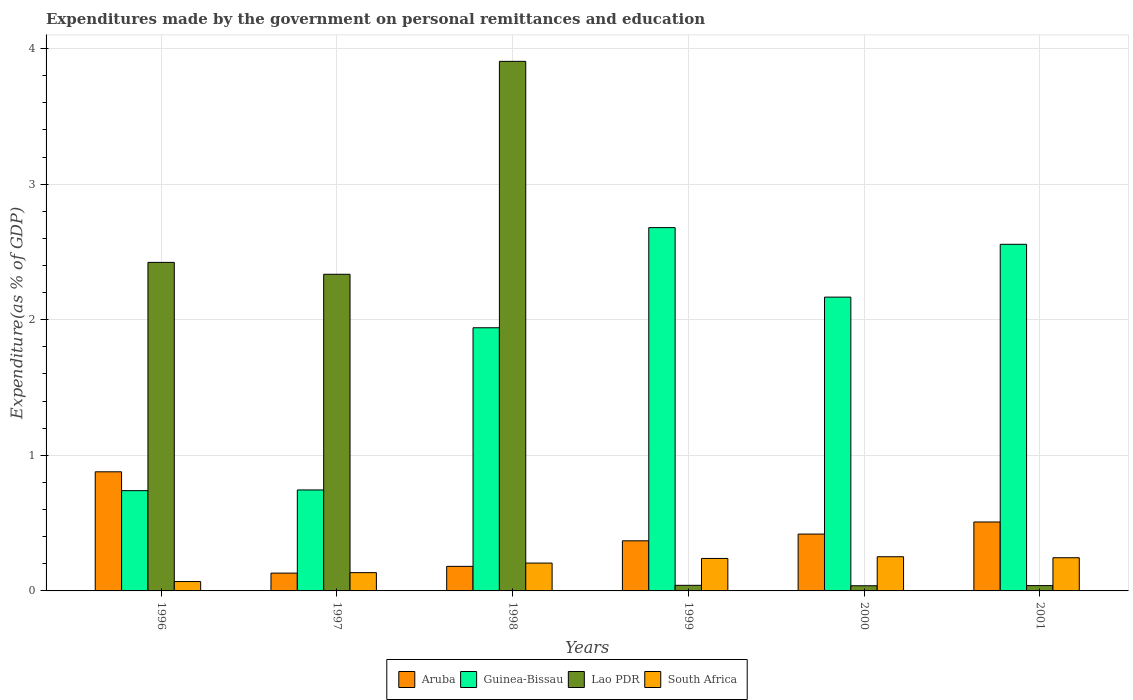Are the number of bars per tick equal to the number of legend labels?
Your answer should be very brief. Yes. Are the number of bars on each tick of the X-axis equal?
Offer a very short reply. Yes. What is the label of the 3rd group of bars from the left?
Ensure brevity in your answer.  1998. What is the expenditures made by the government on personal remittances and education in Guinea-Bissau in 1997?
Keep it short and to the point. 0.74. Across all years, what is the maximum expenditures made by the government on personal remittances and education in Guinea-Bissau?
Give a very brief answer. 2.68. Across all years, what is the minimum expenditures made by the government on personal remittances and education in Aruba?
Your answer should be very brief. 0.13. In which year was the expenditures made by the government on personal remittances and education in Aruba maximum?
Ensure brevity in your answer.  1996. In which year was the expenditures made by the government on personal remittances and education in South Africa minimum?
Keep it short and to the point. 1996. What is the total expenditures made by the government on personal remittances and education in Lao PDR in the graph?
Your answer should be very brief. 8.78. What is the difference between the expenditures made by the government on personal remittances and education in Aruba in 1996 and that in 1997?
Your answer should be compact. 0.75. What is the difference between the expenditures made by the government on personal remittances and education in Lao PDR in 2001 and the expenditures made by the government on personal remittances and education in Aruba in 1999?
Offer a terse response. -0.33. What is the average expenditures made by the government on personal remittances and education in Aruba per year?
Offer a terse response. 0.41. In the year 1998, what is the difference between the expenditures made by the government on personal remittances and education in Lao PDR and expenditures made by the government on personal remittances and education in Aruba?
Provide a succinct answer. 3.72. In how many years, is the expenditures made by the government on personal remittances and education in Aruba greater than 2 %?
Give a very brief answer. 0. What is the ratio of the expenditures made by the government on personal remittances and education in South Africa in 1996 to that in 2000?
Provide a short and direct response. 0.27. Is the difference between the expenditures made by the government on personal remittances and education in Lao PDR in 2000 and 2001 greater than the difference between the expenditures made by the government on personal remittances and education in Aruba in 2000 and 2001?
Keep it short and to the point. Yes. What is the difference between the highest and the second highest expenditures made by the government on personal remittances and education in Lao PDR?
Your answer should be very brief. 1.48. What is the difference between the highest and the lowest expenditures made by the government on personal remittances and education in Aruba?
Offer a terse response. 0.75. In how many years, is the expenditures made by the government on personal remittances and education in South Africa greater than the average expenditures made by the government on personal remittances and education in South Africa taken over all years?
Ensure brevity in your answer.  4. Is the sum of the expenditures made by the government on personal remittances and education in Lao PDR in 1999 and 2000 greater than the maximum expenditures made by the government on personal remittances and education in Guinea-Bissau across all years?
Make the answer very short. No. What does the 4th bar from the left in 1997 represents?
Your answer should be very brief. South Africa. What does the 2nd bar from the right in 1997 represents?
Your response must be concise. Lao PDR. Is it the case that in every year, the sum of the expenditures made by the government on personal remittances and education in Guinea-Bissau and expenditures made by the government on personal remittances and education in Lao PDR is greater than the expenditures made by the government on personal remittances and education in South Africa?
Ensure brevity in your answer.  Yes. How many bars are there?
Your answer should be very brief. 24. Are all the bars in the graph horizontal?
Make the answer very short. No. How many years are there in the graph?
Offer a very short reply. 6. What is the difference between two consecutive major ticks on the Y-axis?
Your response must be concise. 1. Are the values on the major ticks of Y-axis written in scientific E-notation?
Your answer should be compact. No. Does the graph contain any zero values?
Provide a succinct answer. No. How many legend labels are there?
Provide a succinct answer. 4. What is the title of the graph?
Give a very brief answer. Expenditures made by the government on personal remittances and education. What is the label or title of the Y-axis?
Your answer should be compact. Expenditure(as % of GDP). What is the Expenditure(as % of GDP) in Aruba in 1996?
Your response must be concise. 0.88. What is the Expenditure(as % of GDP) in Guinea-Bissau in 1996?
Offer a very short reply. 0.74. What is the Expenditure(as % of GDP) in Lao PDR in 1996?
Give a very brief answer. 2.42. What is the Expenditure(as % of GDP) in South Africa in 1996?
Provide a succinct answer. 0.07. What is the Expenditure(as % of GDP) in Aruba in 1997?
Ensure brevity in your answer.  0.13. What is the Expenditure(as % of GDP) in Guinea-Bissau in 1997?
Keep it short and to the point. 0.74. What is the Expenditure(as % of GDP) of Lao PDR in 1997?
Provide a succinct answer. 2.34. What is the Expenditure(as % of GDP) of South Africa in 1997?
Make the answer very short. 0.13. What is the Expenditure(as % of GDP) in Aruba in 1998?
Keep it short and to the point. 0.18. What is the Expenditure(as % of GDP) of Guinea-Bissau in 1998?
Make the answer very short. 1.94. What is the Expenditure(as % of GDP) of Lao PDR in 1998?
Offer a very short reply. 3.91. What is the Expenditure(as % of GDP) in South Africa in 1998?
Your response must be concise. 0.21. What is the Expenditure(as % of GDP) in Aruba in 1999?
Make the answer very short. 0.37. What is the Expenditure(as % of GDP) in Guinea-Bissau in 1999?
Your answer should be very brief. 2.68. What is the Expenditure(as % of GDP) of Lao PDR in 1999?
Offer a terse response. 0.04. What is the Expenditure(as % of GDP) of South Africa in 1999?
Keep it short and to the point. 0.24. What is the Expenditure(as % of GDP) of Aruba in 2000?
Your answer should be very brief. 0.42. What is the Expenditure(as % of GDP) of Guinea-Bissau in 2000?
Provide a short and direct response. 2.17. What is the Expenditure(as % of GDP) in Lao PDR in 2000?
Your response must be concise. 0.04. What is the Expenditure(as % of GDP) of South Africa in 2000?
Give a very brief answer. 0.25. What is the Expenditure(as % of GDP) in Aruba in 2001?
Ensure brevity in your answer.  0.51. What is the Expenditure(as % of GDP) in Guinea-Bissau in 2001?
Ensure brevity in your answer.  2.56. What is the Expenditure(as % of GDP) of Lao PDR in 2001?
Provide a short and direct response. 0.04. What is the Expenditure(as % of GDP) of South Africa in 2001?
Your answer should be compact. 0.24. Across all years, what is the maximum Expenditure(as % of GDP) in Aruba?
Provide a succinct answer. 0.88. Across all years, what is the maximum Expenditure(as % of GDP) in Guinea-Bissau?
Give a very brief answer. 2.68. Across all years, what is the maximum Expenditure(as % of GDP) of Lao PDR?
Keep it short and to the point. 3.91. Across all years, what is the maximum Expenditure(as % of GDP) in South Africa?
Keep it short and to the point. 0.25. Across all years, what is the minimum Expenditure(as % of GDP) of Aruba?
Make the answer very short. 0.13. Across all years, what is the minimum Expenditure(as % of GDP) of Guinea-Bissau?
Ensure brevity in your answer.  0.74. Across all years, what is the minimum Expenditure(as % of GDP) in Lao PDR?
Provide a succinct answer. 0.04. Across all years, what is the minimum Expenditure(as % of GDP) of South Africa?
Make the answer very short. 0.07. What is the total Expenditure(as % of GDP) of Aruba in the graph?
Make the answer very short. 2.49. What is the total Expenditure(as % of GDP) in Guinea-Bissau in the graph?
Keep it short and to the point. 10.83. What is the total Expenditure(as % of GDP) in Lao PDR in the graph?
Your answer should be compact. 8.78. What is the total Expenditure(as % of GDP) of South Africa in the graph?
Offer a very short reply. 1.15. What is the difference between the Expenditure(as % of GDP) of Aruba in 1996 and that in 1997?
Make the answer very short. 0.75. What is the difference between the Expenditure(as % of GDP) of Guinea-Bissau in 1996 and that in 1997?
Make the answer very short. -0.01. What is the difference between the Expenditure(as % of GDP) of Lao PDR in 1996 and that in 1997?
Provide a short and direct response. 0.09. What is the difference between the Expenditure(as % of GDP) of South Africa in 1996 and that in 1997?
Give a very brief answer. -0.07. What is the difference between the Expenditure(as % of GDP) of Aruba in 1996 and that in 1998?
Give a very brief answer. 0.7. What is the difference between the Expenditure(as % of GDP) in Guinea-Bissau in 1996 and that in 1998?
Your answer should be very brief. -1.2. What is the difference between the Expenditure(as % of GDP) in Lao PDR in 1996 and that in 1998?
Provide a succinct answer. -1.48. What is the difference between the Expenditure(as % of GDP) in South Africa in 1996 and that in 1998?
Give a very brief answer. -0.14. What is the difference between the Expenditure(as % of GDP) in Aruba in 1996 and that in 1999?
Make the answer very short. 0.51. What is the difference between the Expenditure(as % of GDP) of Guinea-Bissau in 1996 and that in 1999?
Keep it short and to the point. -1.94. What is the difference between the Expenditure(as % of GDP) in Lao PDR in 1996 and that in 1999?
Provide a short and direct response. 2.38. What is the difference between the Expenditure(as % of GDP) of South Africa in 1996 and that in 1999?
Keep it short and to the point. -0.17. What is the difference between the Expenditure(as % of GDP) of Aruba in 1996 and that in 2000?
Give a very brief answer. 0.46. What is the difference between the Expenditure(as % of GDP) in Guinea-Bissau in 1996 and that in 2000?
Keep it short and to the point. -1.43. What is the difference between the Expenditure(as % of GDP) in Lao PDR in 1996 and that in 2000?
Your answer should be compact. 2.38. What is the difference between the Expenditure(as % of GDP) of South Africa in 1996 and that in 2000?
Provide a succinct answer. -0.18. What is the difference between the Expenditure(as % of GDP) of Aruba in 1996 and that in 2001?
Offer a very short reply. 0.37. What is the difference between the Expenditure(as % of GDP) of Guinea-Bissau in 1996 and that in 2001?
Your response must be concise. -1.82. What is the difference between the Expenditure(as % of GDP) in Lao PDR in 1996 and that in 2001?
Ensure brevity in your answer.  2.38. What is the difference between the Expenditure(as % of GDP) of South Africa in 1996 and that in 2001?
Provide a succinct answer. -0.18. What is the difference between the Expenditure(as % of GDP) of Aruba in 1997 and that in 1998?
Provide a succinct answer. -0.05. What is the difference between the Expenditure(as % of GDP) of Guinea-Bissau in 1997 and that in 1998?
Offer a terse response. -1.2. What is the difference between the Expenditure(as % of GDP) in Lao PDR in 1997 and that in 1998?
Ensure brevity in your answer.  -1.57. What is the difference between the Expenditure(as % of GDP) in South Africa in 1997 and that in 1998?
Your answer should be compact. -0.07. What is the difference between the Expenditure(as % of GDP) of Aruba in 1997 and that in 1999?
Make the answer very short. -0.24. What is the difference between the Expenditure(as % of GDP) of Guinea-Bissau in 1997 and that in 1999?
Keep it short and to the point. -1.93. What is the difference between the Expenditure(as % of GDP) of Lao PDR in 1997 and that in 1999?
Ensure brevity in your answer.  2.29. What is the difference between the Expenditure(as % of GDP) in South Africa in 1997 and that in 1999?
Give a very brief answer. -0.1. What is the difference between the Expenditure(as % of GDP) in Aruba in 1997 and that in 2000?
Provide a succinct answer. -0.29. What is the difference between the Expenditure(as % of GDP) in Guinea-Bissau in 1997 and that in 2000?
Provide a succinct answer. -1.42. What is the difference between the Expenditure(as % of GDP) in Lao PDR in 1997 and that in 2000?
Ensure brevity in your answer.  2.3. What is the difference between the Expenditure(as % of GDP) of South Africa in 1997 and that in 2000?
Make the answer very short. -0.12. What is the difference between the Expenditure(as % of GDP) of Aruba in 1997 and that in 2001?
Offer a very short reply. -0.38. What is the difference between the Expenditure(as % of GDP) in Guinea-Bissau in 1997 and that in 2001?
Offer a very short reply. -1.81. What is the difference between the Expenditure(as % of GDP) in Lao PDR in 1997 and that in 2001?
Your answer should be compact. 2.3. What is the difference between the Expenditure(as % of GDP) of South Africa in 1997 and that in 2001?
Your answer should be compact. -0.11. What is the difference between the Expenditure(as % of GDP) of Aruba in 1998 and that in 1999?
Provide a short and direct response. -0.19. What is the difference between the Expenditure(as % of GDP) in Guinea-Bissau in 1998 and that in 1999?
Give a very brief answer. -0.74. What is the difference between the Expenditure(as % of GDP) of Lao PDR in 1998 and that in 1999?
Ensure brevity in your answer.  3.86. What is the difference between the Expenditure(as % of GDP) in South Africa in 1998 and that in 1999?
Ensure brevity in your answer.  -0.03. What is the difference between the Expenditure(as % of GDP) in Aruba in 1998 and that in 2000?
Give a very brief answer. -0.24. What is the difference between the Expenditure(as % of GDP) in Guinea-Bissau in 1998 and that in 2000?
Offer a terse response. -0.23. What is the difference between the Expenditure(as % of GDP) in Lao PDR in 1998 and that in 2000?
Provide a short and direct response. 3.87. What is the difference between the Expenditure(as % of GDP) in South Africa in 1998 and that in 2000?
Give a very brief answer. -0.05. What is the difference between the Expenditure(as % of GDP) of Aruba in 1998 and that in 2001?
Ensure brevity in your answer.  -0.33. What is the difference between the Expenditure(as % of GDP) of Guinea-Bissau in 1998 and that in 2001?
Your answer should be compact. -0.62. What is the difference between the Expenditure(as % of GDP) in Lao PDR in 1998 and that in 2001?
Provide a succinct answer. 3.87. What is the difference between the Expenditure(as % of GDP) in South Africa in 1998 and that in 2001?
Make the answer very short. -0.04. What is the difference between the Expenditure(as % of GDP) in Aruba in 1999 and that in 2000?
Offer a terse response. -0.05. What is the difference between the Expenditure(as % of GDP) in Guinea-Bissau in 1999 and that in 2000?
Provide a short and direct response. 0.51. What is the difference between the Expenditure(as % of GDP) of Lao PDR in 1999 and that in 2000?
Offer a very short reply. 0. What is the difference between the Expenditure(as % of GDP) in South Africa in 1999 and that in 2000?
Make the answer very short. -0.01. What is the difference between the Expenditure(as % of GDP) in Aruba in 1999 and that in 2001?
Offer a terse response. -0.14. What is the difference between the Expenditure(as % of GDP) of Guinea-Bissau in 1999 and that in 2001?
Your answer should be very brief. 0.12. What is the difference between the Expenditure(as % of GDP) in Lao PDR in 1999 and that in 2001?
Ensure brevity in your answer.  0. What is the difference between the Expenditure(as % of GDP) in South Africa in 1999 and that in 2001?
Make the answer very short. -0.01. What is the difference between the Expenditure(as % of GDP) in Aruba in 2000 and that in 2001?
Offer a very short reply. -0.09. What is the difference between the Expenditure(as % of GDP) of Guinea-Bissau in 2000 and that in 2001?
Your response must be concise. -0.39. What is the difference between the Expenditure(as % of GDP) in Lao PDR in 2000 and that in 2001?
Ensure brevity in your answer.  -0. What is the difference between the Expenditure(as % of GDP) in South Africa in 2000 and that in 2001?
Provide a short and direct response. 0.01. What is the difference between the Expenditure(as % of GDP) of Aruba in 1996 and the Expenditure(as % of GDP) of Guinea-Bissau in 1997?
Provide a short and direct response. 0.13. What is the difference between the Expenditure(as % of GDP) of Aruba in 1996 and the Expenditure(as % of GDP) of Lao PDR in 1997?
Keep it short and to the point. -1.46. What is the difference between the Expenditure(as % of GDP) in Aruba in 1996 and the Expenditure(as % of GDP) in South Africa in 1997?
Offer a very short reply. 0.74. What is the difference between the Expenditure(as % of GDP) in Guinea-Bissau in 1996 and the Expenditure(as % of GDP) in Lao PDR in 1997?
Offer a very short reply. -1.6. What is the difference between the Expenditure(as % of GDP) of Guinea-Bissau in 1996 and the Expenditure(as % of GDP) of South Africa in 1997?
Your response must be concise. 0.6. What is the difference between the Expenditure(as % of GDP) of Lao PDR in 1996 and the Expenditure(as % of GDP) of South Africa in 1997?
Ensure brevity in your answer.  2.29. What is the difference between the Expenditure(as % of GDP) in Aruba in 1996 and the Expenditure(as % of GDP) in Guinea-Bissau in 1998?
Provide a short and direct response. -1.06. What is the difference between the Expenditure(as % of GDP) in Aruba in 1996 and the Expenditure(as % of GDP) in Lao PDR in 1998?
Provide a short and direct response. -3.03. What is the difference between the Expenditure(as % of GDP) of Aruba in 1996 and the Expenditure(as % of GDP) of South Africa in 1998?
Offer a very short reply. 0.67. What is the difference between the Expenditure(as % of GDP) in Guinea-Bissau in 1996 and the Expenditure(as % of GDP) in Lao PDR in 1998?
Ensure brevity in your answer.  -3.17. What is the difference between the Expenditure(as % of GDP) of Guinea-Bissau in 1996 and the Expenditure(as % of GDP) of South Africa in 1998?
Give a very brief answer. 0.53. What is the difference between the Expenditure(as % of GDP) of Lao PDR in 1996 and the Expenditure(as % of GDP) of South Africa in 1998?
Give a very brief answer. 2.22. What is the difference between the Expenditure(as % of GDP) in Aruba in 1996 and the Expenditure(as % of GDP) in Guinea-Bissau in 1999?
Your answer should be compact. -1.8. What is the difference between the Expenditure(as % of GDP) of Aruba in 1996 and the Expenditure(as % of GDP) of Lao PDR in 1999?
Give a very brief answer. 0.84. What is the difference between the Expenditure(as % of GDP) of Aruba in 1996 and the Expenditure(as % of GDP) of South Africa in 1999?
Ensure brevity in your answer.  0.64. What is the difference between the Expenditure(as % of GDP) in Guinea-Bissau in 1996 and the Expenditure(as % of GDP) in Lao PDR in 1999?
Ensure brevity in your answer.  0.7. What is the difference between the Expenditure(as % of GDP) in Guinea-Bissau in 1996 and the Expenditure(as % of GDP) in South Africa in 1999?
Give a very brief answer. 0.5. What is the difference between the Expenditure(as % of GDP) of Lao PDR in 1996 and the Expenditure(as % of GDP) of South Africa in 1999?
Make the answer very short. 2.18. What is the difference between the Expenditure(as % of GDP) in Aruba in 1996 and the Expenditure(as % of GDP) in Guinea-Bissau in 2000?
Give a very brief answer. -1.29. What is the difference between the Expenditure(as % of GDP) of Aruba in 1996 and the Expenditure(as % of GDP) of Lao PDR in 2000?
Your answer should be very brief. 0.84. What is the difference between the Expenditure(as % of GDP) in Aruba in 1996 and the Expenditure(as % of GDP) in South Africa in 2000?
Your answer should be compact. 0.63. What is the difference between the Expenditure(as % of GDP) in Guinea-Bissau in 1996 and the Expenditure(as % of GDP) in Lao PDR in 2000?
Offer a terse response. 0.7. What is the difference between the Expenditure(as % of GDP) in Guinea-Bissau in 1996 and the Expenditure(as % of GDP) in South Africa in 2000?
Keep it short and to the point. 0.49. What is the difference between the Expenditure(as % of GDP) of Lao PDR in 1996 and the Expenditure(as % of GDP) of South Africa in 2000?
Your answer should be compact. 2.17. What is the difference between the Expenditure(as % of GDP) of Aruba in 1996 and the Expenditure(as % of GDP) of Guinea-Bissau in 2001?
Offer a terse response. -1.68. What is the difference between the Expenditure(as % of GDP) in Aruba in 1996 and the Expenditure(as % of GDP) in Lao PDR in 2001?
Offer a very short reply. 0.84. What is the difference between the Expenditure(as % of GDP) of Aruba in 1996 and the Expenditure(as % of GDP) of South Africa in 2001?
Give a very brief answer. 0.63. What is the difference between the Expenditure(as % of GDP) of Guinea-Bissau in 1996 and the Expenditure(as % of GDP) of Lao PDR in 2001?
Your response must be concise. 0.7. What is the difference between the Expenditure(as % of GDP) of Guinea-Bissau in 1996 and the Expenditure(as % of GDP) of South Africa in 2001?
Offer a very short reply. 0.49. What is the difference between the Expenditure(as % of GDP) in Lao PDR in 1996 and the Expenditure(as % of GDP) in South Africa in 2001?
Offer a terse response. 2.18. What is the difference between the Expenditure(as % of GDP) of Aruba in 1997 and the Expenditure(as % of GDP) of Guinea-Bissau in 1998?
Provide a short and direct response. -1.81. What is the difference between the Expenditure(as % of GDP) in Aruba in 1997 and the Expenditure(as % of GDP) in Lao PDR in 1998?
Provide a succinct answer. -3.77. What is the difference between the Expenditure(as % of GDP) of Aruba in 1997 and the Expenditure(as % of GDP) of South Africa in 1998?
Offer a terse response. -0.07. What is the difference between the Expenditure(as % of GDP) of Guinea-Bissau in 1997 and the Expenditure(as % of GDP) of Lao PDR in 1998?
Make the answer very short. -3.16. What is the difference between the Expenditure(as % of GDP) of Guinea-Bissau in 1997 and the Expenditure(as % of GDP) of South Africa in 1998?
Make the answer very short. 0.54. What is the difference between the Expenditure(as % of GDP) in Lao PDR in 1997 and the Expenditure(as % of GDP) in South Africa in 1998?
Offer a terse response. 2.13. What is the difference between the Expenditure(as % of GDP) of Aruba in 1997 and the Expenditure(as % of GDP) of Guinea-Bissau in 1999?
Offer a very short reply. -2.55. What is the difference between the Expenditure(as % of GDP) in Aruba in 1997 and the Expenditure(as % of GDP) in Lao PDR in 1999?
Ensure brevity in your answer.  0.09. What is the difference between the Expenditure(as % of GDP) in Aruba in 1997 and the Expenditure(as % of GDP) in South Africa in 1999?
Offer a terse response. -0.11. What is the difference between the Expenditure(as % of GDP) of Guinea-Bissau in 1997 and the Expenditure(as % of GDP) of Lao PDR in 1999?
Your response must be concise. 0.7. What is the difference between the Expenditure(as % of GDP) of Guinea-Bissau in 1997 and the Expenditure(as % of GDP) of South Africa in 1999?
Your answer should be very brief. 0.51. What is the difference between the Expenditure(as % of GDP) in Lao PDR in 1997 and the Expenditure(as % of GDP) in South Africa in 1999?
Offer a very short reply. 2.1. What is the difference between the Expenditure(as % of GDP) in Aruba in 1997 and the Expenditure(as % of GDP) in Guinea-Bissau in 2000?
Ensure brevity in your answer.  -2.04. What is the difference between the Expenditure(as % of GDP) in Aruba in 1997 and the Expenditure(as % of GDP) in Lao PDR in 2000?
Offer a very short reply. 0.09. What is the difference between the Expenditure(as % of GDP) of Aruba in 1997 and the Expenditure(as % of GDP) of South Africa in 2000?
Your response must be concise. -0.12. What is the difference between the Expenditure(as % of GDP) in Guinea-Bissau in 1997 and the Expenditure(as % of GDP) in Lao PDR in 2000?
Keep it short and to the point. 0.71. What is the difference between the Expenditure(as % of GDP) in Guinea-Bissau in 1997 and the Expenditure(as % of GDP) in South Africa in 2000?
Keep it short and to the point. 0.49. What is the difference between the Expenditure(as % of GDP) of Lao PDR in 1997 and the Expenditure(as % of GDP) of South Africa in 2000?
Provide a succinct answer. 2.08. What is the difference between the Expenditure(as % of GDP) of Aruba in 1997 and the Expenditure(as % of GDP) of Guinea-Bissau in 2001?
Your response must be concise. -2.43. What is the difference between the Expenditure(as % of GDP) of Aruba in 1997 and the Expenditure(as % of GDP) of Lao PDR in 2001?
Your answer should be very brief. 0.09. What is the difference between the Expenditure(as % of GDP) of Aruba in 1997 and the Expenditure(as % of GDP) of South Africa in 2001?
Provide a short and direct response. -0.11. What is the difference between the Expenditure(as % of GDP) of Guinea-Bissau in 1997 and the Expenditure(as % of GDP) of Lao PDR in 2001?
Provide a short and direct response. 0.71. What is the difference between the Expenditure(as % of GDP) in Guinea-Bissau in 1997 and the Expenditure(as % of GDP) in South Africa in 2001?
Offer a very short reply. 0.5. What is the difference between the Expenditure(as % of GDP) of Lao PDR in 1997 and the Expenditure(as % of GDP) of South Africa in 2001?
Keep it short and to the point. 2.09. What is the difference between the Expenditure(as % of GDP) of Aruba in 1998 and the Expenditure(as % of GDP) of Guinea-Bissau in 1999?
Make the answer very short. -2.5. What is the difference between the Expenditure(as % of GDP) of Aruba in 1998 and the Expenditure(as % of GDP) of Lao PDR in 1999?
Provide a short and direct response. 0.14. What is the difference between the Expenditure(as % of GDP) in Aruba in 1998 and the Expenditure(as % of GDP) in South Africa in 1999?
Make the answer very short. -0.06. What is the difference between the Expenditure(as % of GDP) of Guinea-Bissau in 1998 and the Expenditure(as % of GDP) of Lao PDR in 1999?
Give a very brief answer. 1.9. What is the difference between the Expenditure(as % of GDP) in Guinea-Bissau in 1998 and the Expenditure(as % of GDP) in South Africa in 1999?
Offer a terse response. 1.7. What is the difference between the Expenditure(as % of GDP) of Lao PDR in 1998 and the Expenditure(as % of GDP) of South Africa in 1999?
Give a very brief answer. 3.67. What is the difference between the Expenditure(as % of GDP) of Aruba in 1998 and the Expenditure(as % of GDP) of Guinea-Bissau in 2000?
Ensure brevity in your answer.  -1.99. What is the difference between the Expenditure(as % of GDP) in Aruba in 1998 and the Expenditure(as % of GDP) in Lao PDR in 2000?
Give a very brief answer. 0.14. What is the difference between the Expenditure(as % of GDP) of Aruba in 1998 and the Expenditure(as % of GDP) of South Africa in 2000?
Provide a short and direct response. -0.07. What is the difference between the Expenditure(as % of GDP) of Guinea-Bissau in 1998 and the Expenditure(as % of GDP) of Lao PDR in 2000?
Your answer should be compact. 1.9. What is the difference between the Expenditure(as % of GDP) of Guinea-Bissau in 1998 and the Expenditure(as % of GDP) of South Africa in 2000?
Ensure brevity in your answer.  1.69. What is the difference between the Expenditure(as % of GDP) of Lao PDR in 1998 and the Expenditure(as % of GDP) of South Africa in 2000?
Your answer should be compact. 3.65. What is the difference between the Expenditure(as % of GDP) in Aruba in 1998 and the Expenditure(as % of GDP) in Guinea-Bissau in 2001?
Your answer should be very brief. -2.38. What is the difference between the Expenditure(as % of GDP) in Aruba in 1998 and the Expenditure(as % of GDP) in Lao PDR in 2001?
Provide a succinct answer. 0.14. What is the difference between the Expenditure(as % of GDP) of Aruba in 1998 and the Expenditure(as % of GDP) of South Africa in 2001?
Keep it short and to the point. -0.06. What is the difference between the Expenditure(as % of GDP) in Guinea-Bissau in 1998 and the Expenditure(as % of GDP) in Lao PDR in 2001?
Provide a succinct answer. 1.9. What is the difference between the Expenditure(as % of GDP) in Guinea-Bissau in 1998 and the Expenditure(as % of GDP) in South Africa in 2001?
Keep it short and to the point. 1.7. What is the difference between the Expenditure(as % of GDP) in Lao PDR in 1998 and the Expenditure(as % of GDP) in South Africa in 2001?
Your answer should be very brief. 3.66. What is the difference between the Expenditure(as % of GDP) of Aruba in 1999 and the Expenditure(as % of GDP) of Guinea-Bissau in 2000?
Provide a succinct answer. -1.8. What is the difference between the Expenditure(as % of GDP) of Aruba in 1999 and the Expenditure(as % of GDP) of Lao PDR in 2000?
Ensure brevity in your answer.  0.33. What is the difference between the Expenditure(as % of GDP) of Aruba in 1999 and the Expenditure(as % of GDP) of South Africa in 2000?
Make the answer very short. 0.12. What is the difference between the Expenditure(as % of GDP) of Guinea-Bissau in 1999 and the Expenditure(as % of GDP) of Lao PDR in 2000?
Your answer should be very brief. 2.64. What is the difference between the Expenditure(as % of GDP) in Guinea-Bissau in 1999 and the Expenditure(as % of GDP) in South Africa in 2000?
Keep it short and to the point. 2.43. What is the difference between the Expenditure(as % of GDP) of Lao PDR in 1999 and the Expenditure(as % of GDP) of South Africa in 2000?
Your response must be concise. -0.21. What is the difference between the Expenditure(as % of GDP) in Aruba in 1999 and the Expenditure(as % of GDP) in Guinea-Bissau in 2001?
Provide a short and direct response. -2.19. What is the difference between the Expenditure(as % of GDP) in Aruba in 1999 and the Expenditure(as % of GDP) in Lao PDR in 2001?
Make the answer very short. 0.33. What is the difference between the Expenditure(as % of GDP) in Aruba in 1999 and the Expenditure(as % of GDP) in South Africa in 2001?
Make the answer very short. 0.12. What is the difference between the Expenditure(as % of GDP) in Guinea-Bissau in 1999 and the Expenditure(as % of GDP) in Lao PDR in 2001?
Your answer should be compact. 2.64. What is the difference between the Expenditure(as % of GDP) in Guinea-Bissau in 1999 and the Expenditure(as % of GDP) in South Africa in 2001?
Keep it short and to the point. 2.43. What is the difference between the Expenditure(as % of GDP) in Lao PDR in 1999 and the Expenditure(as % of GDP) in South Africa in 2001?
Make the answer very short. -0.2. What is the difference between the Expenditure(as % of GDP) of Aruba in 2000 and the Expenditure(as % of GDP) of Guinea-Bissau in 2001?
Give a very brief answer. -2.14. What is the difference between the Expenditure(as % of GDP) of Aruba in 2000 and the Expenditure(as % of GDP) of Lao PDR in 2001?
Provide a short and direct response. 0.38. What is the difference between the Expenditure(as % of GDP) in Aruba in 2000 and the Expenditure(as % of GDP) in South Africa in 2001?
Your answer should be very brief. 0.17. What is the difference between the Expenditure(as % of GDP) of Guinea-Bissau in 2000 and the Expenditure(as % of GDP) of Lao PDR in 2001?
Offer a very short reply. 2.13. What is the difference between the Expenditure(as % of GDP) in Guinea-Bissau in 2000 and the Expenditure(as % of GDP) in South Africa in 2001?
Keep it short and to the point. 1.92. What is the difference between the Expenditure(as % of GDP) in Lao PDR in 2000 and the Expenditure(as % of GDP) in South Africa in 2001?
Offer a very short reply. -0.21. What is the average Expenditure(as % of GDP) in Aruba per year?
Offer a terse response. 0.41. What is the average Expenditure(as % of GDP) in Guinea-Bissau per year?
Keep it short and to the point. 1.8. What is the average Expenditure(as % of GDP) of Lao PDR per year?
Provide a short and direct response. 1.46. What is the average Expenditure(as % of GDP) in South Africa per year?
Your answer should be very brief. 0.19. In the year 1996, what is the difference between the Expenditure(as % of GDP) in Aruba and Expenditure(as % of GDP) in Guinea-Bissau?
Give a very brief answer. 0.14. In the year 1996, what is the difference between the Expenditure(as % of GDP) in Aruba and Expenditure(as % of GDP) in Lao PDR?
Offer a terse response. -1.54. In the year 1996, what is the difference between the Expenditure(as % of GDP) in Aruba and Expenditure(as % of GDP) in South Africa?
Make the answer very short. 0.81. In the year 1996, what is the difference between the Expenditure(as % of GDP) in Guinea-Bissau and Expenditure(as % of GDP) in Lao PDR?
Offer a very short reply. -1.68. In the year 1996, what is the difference between the Expenditure(as % of GDP) of Guinea-Bissau and Expenditure(as % of GDP) of South Africa?
Your answer should be compact. 0.67. In the year 1996, what is the difference between the Expenditure(as % of GDP) of Lao PDR and Expenditure(as % of GDP) of South Africa?
Your answer should be very brief. 2.35. In the year 1997, what is the difference between the Expenditure(as % of GDP) in Aruba and Expenditure(as % of GDP) in Guinea-Bissau?
Your answer should be compact. -0.61. In the year 1997, what is the difference between the Expenditure(as % of GDP) of Aruba and Expenditure(as % of GDP) of Lao PDR?
Ensure brevity in your answer.  -2.2. In the year 1997, what is the difference between the Expenditure(as % of GDP) in Aruba and Expenditure(as % of GDP) in South Africa?
Your answer should be compact. -0. In the year 1997, what is the difference between the Expenditure(as % of GDP) of Guinea-Bissau and Expenditure(as % of GDP) of Lao PDR?
Your response must be concise. -1.59. In the year 1997, what is the difference between the Expenditure(as % of GDP) in Guinea-Bissau and Expenditure(as % of GDP) in South Africa?
Offer a terse response. 0.61. In the year 1997, what is the difference between the Expenditure(as % of GDP) of Lao PDR and Expenditure(as % of GDP) of South Africa?
Provide a short and direct response. 2.2. In the year 1998, what is the difference between the Expenditure(as % of GDP) in Aruba and Expenditure(as % of GDP) in Guinea-Bissau?
Offer a very short reply. -1.76. In the year 1998, what is the difference between the Expenditure(as % of GDP) of Aruba and Expenditure(as % of GDP) of Lao PDR?
Provide a short and direct response. -3.72. In the year 1998, what is the difference between the Expenditure(as % of GDP) of Aruba and Expenditure(as % of GDP) of South Africa?
Offer a very short reply. -0.02. In the year 1998, what is the difference between the Expenditure(as % of GDP) of Guinea-Bissau and Expenditure(as % of GDP) of Lao PDR?
Your response must be concise. -1.96. In the year 1998, what is the difference between the Expenditure(as % of GDP) in Guinea-Bissau and Expenditure(as % of GDP) in South Africa?
Your response must be concise. 1.74. In the year 1998, what is the difference between the Expenditure(as % of GDP) in Lao PDR and Expenditure(as % of GDP) in South Africa?
Your answer should be compact. 3.7. In the year 1999, what is the difference between the Expenditure(as % of GDP) of Aruba and Expenditure(as % of GDP) of Guinea-Bissau?
Your response must be concise. -2.31. In the year 1999, what is the difference between the Expenditure(as % of GDP) in Aruba and Expenditure(as % of GDP) in Lao PDR?
Ensure brevity in your answer.  0.33. In the year 1999, what is the difference between the Expenditure(as % of GDP) in Aruba and Expenditure(as % of GDP) in South Africa?
Offer a very short reply. 0.13. In the year 1999, what is the difference between the Expenditure(as % of GDP) in Guinea-Bissau and Expenditure(as % of GDP) in Lao PDR?
Offer a terse response. 2.64. In the year 1999, what is the difference between the Expenditure(as % of GDP) of Guinea-Bissau and Expenditure(as % of GDP) of South Africa?
Keep it short and to the point. 2.44. In the year 1999, what is the difference between the Expenditure(as % of GDP) in Lao PDR and Expenditure(as % of GDP) in South Africa?
Provide a succinct answer. -0.2. In the year 2000, what is the difference between the Expenditure(as % of GDP) in Aruba and Expenditure(as % of GDP) in Guinea-Bissau?
Your response must be concise. -1.75. In the year 2000, what is the difference between the Expenditure(as % of GDP) in Aruba and Expenditure(as % of GDP) in Lao PDR?
Offer a very short reply. 0.38. In the year 2000, what is the difference between the Expenditure(as % of GDP) in Aruba and Expenditure(as % of GDP) in South Africa?
Your response must be concise. 0.17. In the year 2000, what is the difference between the Expenditure(as % of GDP) of Guinea-Bissau and Expenditure(as % of GDP) of Lao PDR?
Make the answer very short. 2.13. In the year 2000, what is the difference between the Expenditure(as % of GDP) of Guinea-Bissau and Expenditure(as % of GDP) of South Africa?
Your answer should be compact. 1.91. In the year 2000, what is the difference between the Expenditure(as % of GDP) of Lao PDR and Expenditure(as % of GDP) of South Africa?
Offer a terse response. -0.21. In the year 2001, what is the difference between the Expenditure(as % of GDP) of Aruba and Expenditure(as % of GDP) of Guinea-Bissau?
Your response must be concise. -2.05. In the year 2001, what is the difference between the Expenditure(as % of GDP) of Aruba and Expenditure(as % of GDP) of Lao PDR?
Your answer should be very brief. 0.47. In the year 2001, what is the difference between the Expenditure(as % of GDP) in Aruba and Expenditure(as % of GDP) in South Africa?
Offer a terse response. 0.26. In the year 2001, what is the difference between the Expenditure(as % of GDP) in Guinea-Bissau and Expenditure(as % of GDP) in Lao PDR?
Make the answer very short. 2.52. In the year 2001, what is the difference between the Expenditure(as % of GDP) in Guinea-Bissau and Expenditure(as % of GDP) in South Africa?
Your response must be concise. 2.31. In the year 2001, what is the difference between the Expenditure(as % of GDP) of Lao PDR and Expenditure(as % of GDP) of South Africa?
Keep it short and to the point. -0.21. What is the ratio of the Expenditure(as % of GDP) of Aruba in 1996 to that in 1997?
Give a very brief answer. 6.69. What is the ratio of the Expenditure(as % of GDP) of Lao PDR in 1996 to that in 1997?
Provide a short and direct response. 1.04. What is the ratio of the Expenditure(as % of GDP) in South Africa in 1996 to that in 1997?
Keep it short and to the point. 0.51. What is the ratio of the Expenditure(as % of GDP) in Aruba in 1996 to that in 1998?
Give a very brief answer. 4.85. What is the ratio of the Expenditure(as % of GDP) in Guinea-Bissau in 1996 to that in 1998?
Provide a short and direct response. 0.38. What is the ratio of the Expenditure(as % of GDP) in Lao PDR in 1996 to that in 1998?
Offer a very short reply. 0.62. What is the ratio of the Expenditure(as % of GDP) in South Africa in 1996 to that in 1998?
Keep it short and to the point. 0.34. What is the ratio of the Expenditure(as % of GDP) in Aruba in 1996 to that in 1999?
Your answer should be compact. 2.38. What is the ratio of the Expenditure(as % of GDP) in Guinea-Bissau in 1996 to that in 1999?
Make the answer very short. 0.28. What is the ratio of the Expenditure(as % of GDP) of Lao PDR in 1996 to that in 1999?
Ensure brevity in your answer.  58.74. What is the ratio of the Expenditure(as % of GDP) in South Africa in 1996 to that in 1999?
Keep it short and to the point. 0.29. What is the ratio of the Expenditure(as % of GDP) of Aruba in 1996 to that in 2000?
Provide a short and direct response. 2.1. What is the ratio of the Expenditure(as % of GDP) of Guinea-Bissau in 1996 to that in 2000?
Keep it short and to the point. 0.34. What is the ratio of the Expenditure(as % of GDP) of Lao PDR in 1996 to that in 2000?
Offer a very short reply. 63.56. What is the ratio of the Expenditure(as % of GDP) in South Africa in 1996 to that in 2000?
Your answer should be compact. 0.27. What is the ratio of the Expenditure(as % of GDP) of Aruba in 1996 to that in 2001?
Give a very brief answer. 1.73. What is the ratio of the Expenditure(as % of GDP) of Guinea-Bissau in 1996 to that in 2001?
Keep it short and to the point. 0.29. What is the ratio of the Expenditure(as % of GDP) in Lao PDR in 1996 to that in 2001?
Offer a very short reply. 61.7. What is the ratio of the Expenditure(as % of GDP) of South Africa in 1996 to that in 2001?
Make the answer very short. 0.28. What is the ratio of the Expenditure(as % of GDP) in Aruba in 1997 to that in 1998?
Offer a terse response. 0.72. What is the ratio of the Expenditure(as % of GDP) in Guinea-Bissau in 1997 to that in 1998?
Your answer should be compact. 0.38. What is the ratio of the Expenditure(as % of GDP) of Lao PDR in 1997 to that in 1998?
Ensure brevity in your answer.  0.6. What is the ratio of the Expenditure(as % of GDP) of South Africa in 1997 to that in 1998?
Keep it short and to the point. 0.66. What is the ratio of the Expenditure(as % of GDP) of Aruba in 1997 to that in 1999?
Provide a short and direct response. 0.36. What is the ratio of the Expenditure(as % of GDP) of Guinea-Bissau in 1997 to that in 1999?
Ensure brevity in your answer.  0.28. What is the ratio of the Expenditure(as % of GDP) in Lao PDR in 1997 to that in 1999?
Ensure brevity in your answer.  56.61. What is the ratio of the Expenditure(as % of GDP) in South Africa in 1997 to that in 1999?
Provide a short and direct response. 0.56. What is the ratio of the Expenditure(as % of GDP) in Aruba in 1997 to that in 2000?
Ensure brevity in your answer.  0.31. What is the ratio of the Expenditure(as % of GDP) in Guinea-Bissau in 1997 to that in 2000?
Provide a succinct answer. 0.34. What is the ratio of the Expenditure(as % of GDP) of Lao PDR in 1997 to that in 2000?
Offer a terse response. 61.26. What is the ratio of the Expenditure(as % of GDP) in South Africa in 1997 to that in 2000?
Offer a very short reply. 0.54. What is the ratio of the Expenditure(as % of GDP) in Aruba in 1997 to that in 2001?
Your answer should be compact. 0.26. What is the ratio of the Expenditure(as % of GDP) of Guinea-Bissau in 1997 to that in 2001?
Your response must be concise. 0.29. What is the ratio of the Expenditure(as % of GDP) in Lao PDR in 1997 to that in 2001?
Ensure brevity in your answer.  59.47. What is the ratio of the Expenditure(as % of GDP) in South Africa in 1997 to that in 2001?
Ensure brevity in your answer.  0.55. What is the ratio of the Expenditure(as % of GDP) of Aruba in 1998 to that in 1999?
Give a very brief answer. 0.49. What is the ratio of the Expenditure(as % of GDP) in Guinea-Bissau in 1998 to that in 1999?
Keep it short and to the point. 0.72. What is the ratio of the Expenditure(as % of GDP) of Lao PDR in 1998 to that in 1999?
Keep it short and to the point. 94.68. What is the ratio of the Expenditure(as % of GDP) in South Africa in 1998 to that in 1999?
Your answer should be very brief. 0.86. What is the ratio of the Expenditure(as % of GDP) in Aruba in 1998 to that in 2000?
Your response must be concise. 0.43. What is the ratio of the Expenditure(as % of GDP) in Guinea-Bissau in 1998 to that in 2000?
Give a very brief answer. 0.9. What is the ratio of the Expenditure(as % of GDP) of Lao PDR in 1998 to that in 2000?
Make the answer very short. 102.45. What is the ratio of the Expenditure(as % of GDP) in South Africa in 1998 to that in 2000?
Offer a terse response. 0.81. What is the ratio of the Expenditure(as % of GDP) of Aruba in 1998 to that in 2001?
Your response must be concise. 0.36. What is the ratio of the Expenditure(as % of GDP) of Guinea-Bissau in 1998 to that in 2001?
Ensure brevity in your answer.  0.76. What is the ratio of the Expenditure(as % of GDP) of Lao PDR in 1998 to that in 2001?
Offer a terse response. 99.45. What is the ratio of the Expenditure(as % of GDP) of South Africa in 1998 to that in 2001?
Your answer should be compact. 0.84. What is the ratio of the Expenditure(as % of GDP) of Aruba in 1999 to that in 2000?
Provide a short and direct response. 0.88. What is the ratio of the Expenditure(as % of GDP) in Guinea-Bissau in 1999 to that in 2000?
Give a very brief answer. 1.24. What is the ratio of the Expenditure(as % of GDP) in Lao PDR in 1999 to that in 2000?
Keep it short and to the point. 1.08. What is the ratio of the Expenditure(as % of GDP) of South Africa in 1999 to that in 2000?
Your answer should be compact. 0.95. What is the ratio of the Expenditure(as % of GDP) in Aruba in 1999 to that in 2001?
Offer a terse response. 0.73. What is the ratio of the Expenditure(as % of GDP) in Guinea-Bissau in 1999 to that in 2001?
Your answer should be very brief. 1.05. What is the ratio of the Expenditure(as % of GDP) of Lao PDR in 1999 to that in 2001?
Provide a short and direct response. 1.05. What is the ratio of the Expenditure(as % of GDP) of South Africa in 1999 to that in 2001?
Offer a very short reply. 0.98. What is the ratio of the Expenditure(as % of GDP) in Aruba in 2000 to that in 2001?
Provide a short and direct response. 0.82. What is the ratio of the Expenditure(as % of GDP) of Guinea-Bissau in 2000 to that in 2001?
Give a very brief answer. 0.85. What is the ratio of the Expenditure(as % of GDP) in Lao PDR in 2000 to that in 2001?
Ensure brevity in your answer.  0.97. What is the ratio of the Expenditure(as % of GDP) of South Africa in 2000 to that in 2001?
Your answer should be compact. 1.03. What is the difference between the highest and the second highest Expenditure(as % of GDP) of Aruba?
Your response must be concise. 0.37. What is the difference between the highest and the second highest Expenditure(as % of GDP) in Guinea-Bissau?
Ensure brevity in your answer.  0.12. What is the difference between the highest and the second highest Expenditure(as % of GDP) in Lao PDR?
Keep it short and to the point. 1.48. What is the difference between the highest and the second highest Expenditure(as % of GDP) of South Africa?
Offer a terse response. 0.01. What is the difference between the highest and the lowest Expenditure(as % of GDP) of Aruba?
Provide a succinct answer. 0.75. What is the difference between the highest and the lowest Expenditure(as % of GDP) in Guinea-Bissau?
Give a very brief answer. 1.94. What is the difference between the highest and the lowest Expenditure(as % of GDP) of Lao PDR?
Your answer should be compact. 3.87. What is the difference between the highest and the lowest Expenditure(as % of GDP) in South Africa?
Keep it short and to the point. 0.18. 